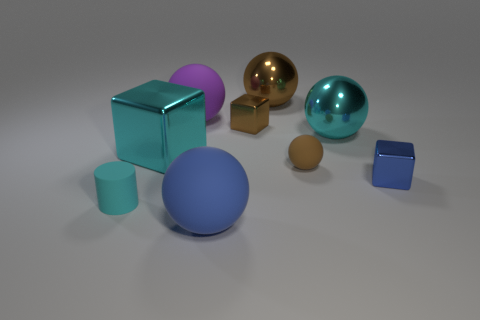Subtract all cyan metal spheres. How many spheres are left? 4 Subtract 1 spheres. How many spheres are left? 4 Subtract all purple balls. How many balls are left? 4 Subtract all yellow spheres. Subtract all gray cylinders. How many spheres are left? 5 Add 1 small cyan rubber things. How many objects exist? 10 Subtract all cylinders. How many objects are left? 8 Add 8 small brown metal cubes. How many small brown metal cubes exist? 9 Subtract 0 blue cylinders. How many objects are left? 9 Subtract all tiny blue metal objects. Subtract all tiny gray blocks. How many objects are left? 8 Add 6 shiny blocks. How many shiny blocks are left? 9 